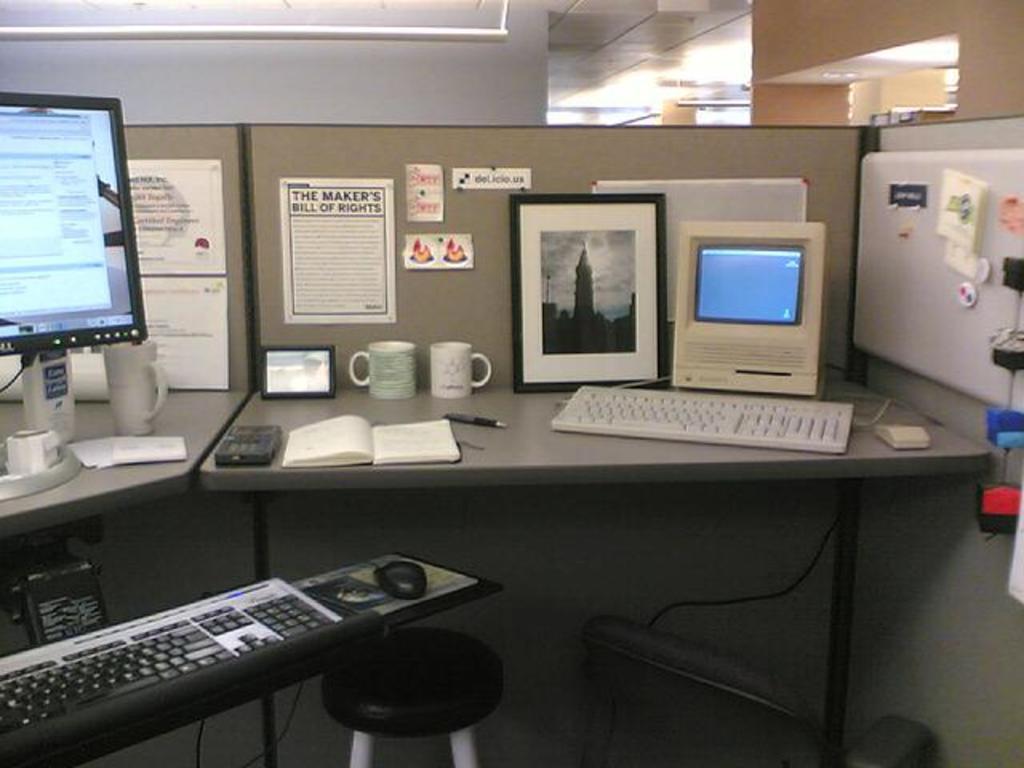What document is on the wall above the picture frame and coffee mugs?
Offer a very short reply. The maker's bill of rights. 